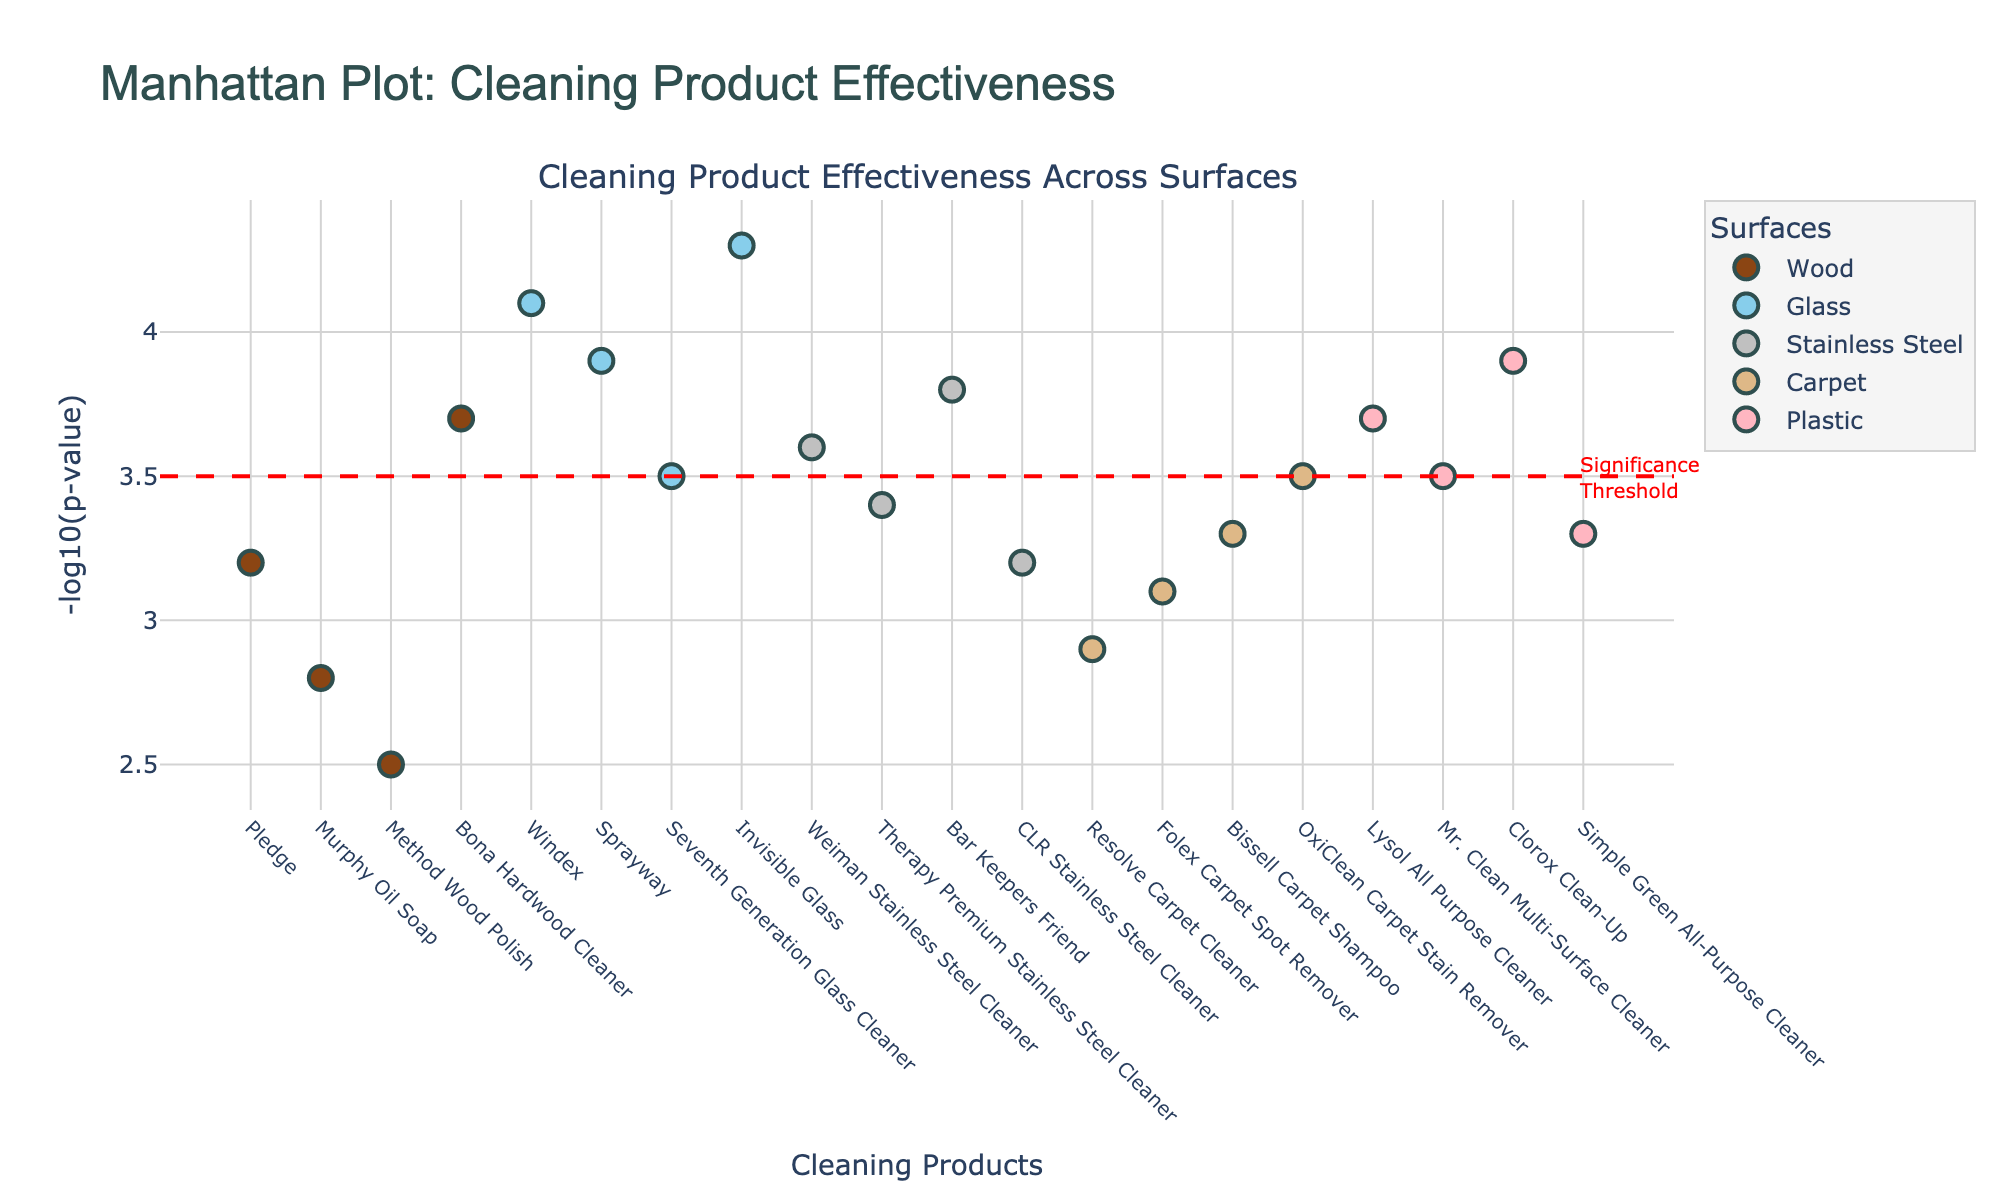Which surface has the product with the highest -log10(p-value)? To find the surface with the highest -log10(p-value), we look for the point plotted highest on the y-axis. The point representing Invisible Glass cleaner on the Glass surface has the highest -log10(p-value).
Answer: Glass How many products have a -log10(p-value) above the significance threshold? The significance threshold is marked by a dashed red line at -log10(p-value) = 3.5. Count the number of points above this line.
Answer: 8 Which product has the lowest -log10(p-value) for Wood surfaces? Locate the products for Wood surfaces on the x-axis and compare their -log10(p-values). Method Wood Polish has the lowest at 2.5.
Answer: Method Wood Polish Compare the effectiveness of cleaning products for Wood and Glass surfaces. Which surface shows greater effectiveness overall? Effectiveness is indicated by higher -log10(p-values). Compare the points for Wood and Glass surfaces. Glass products on average have higher -log10(p-values) compared to Wood products.
Answer: Glass How does the effectiveness of Mr. Clean Multi-Surface Cleaner compare to Clorox Clean-Up on Plastic surfaces? Locate both products on the x-axis for Plastic surfaces and compare their -log10(p-values). Clorox Clean-Up has a higher value than Mr. Clean Multi-Surface Cleaner, indicating greater effectiveness.
Answer: Clorox Clean-Up What is the range of -log10(p-values) for products on Stainless Steel surfaces? The range is found by subtracting the minimum -log10(p-value) from the maximum for Stainless Steel surfaces. Max: Bar Keepers Friend (3.8), Min: Therapy Premium Stainless Steel Cleaner (3.4). So, the range is 3.8 - 3.4 = 0.4.
Answer: 0.4 Which product has the highest -log10(p-value) on Plastic surfaces? Identify the point highest on the y-axis for Plastic surfaces. Clorox Clean-Up has the highest -log10(p-value) for Plastic surfaces.
Answer: Clorox Clean-Up Are there any surfaces where all products have a -log10(p-value) above 3.0? Check the -log10(p-values) for all products on each surface. All products for Glass and Stainless Steel surfaces have -log10(p-values) above 3.0.
Answer: Glass, Stainless Steel 